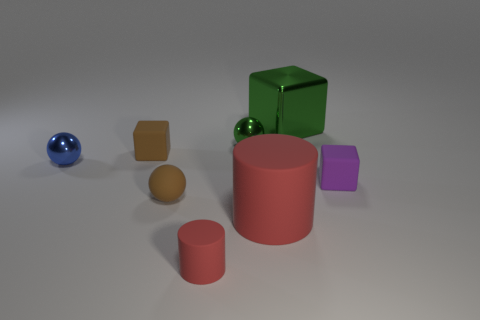How many red cylinders must be subtracted to get 1 red cylinders? 1 Add 1 big things. How many objects exist? 9 Subtract all cylinders. How many objects are left? 6 Add 1 brown spheres. How many brown spheres exist? 2 Subtract 0 green cylinders. How many objects are left? 8 Subtract all tiny metallic spheres. Subtract all red matte cylinders. How many objects are left? 4 Add 3 small purple rubber blocks. How many small purple rubber blocks are left? 4 